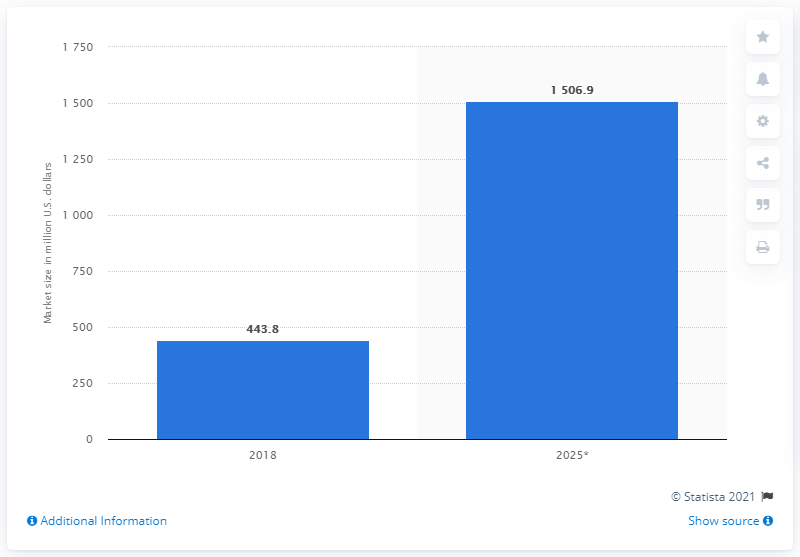Give some essential details in this illustration. The expected size of the body-worn camera market in 2025 is projected to be 1506.9.. 